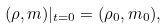Convert formula to latex. <formula><loc_0><loc_0><loc_500><loc_500>( \rho , m ) | _ { t = 0 } = ( \rho _ { 0 } , m _ { 0 } ) ,</formula> 